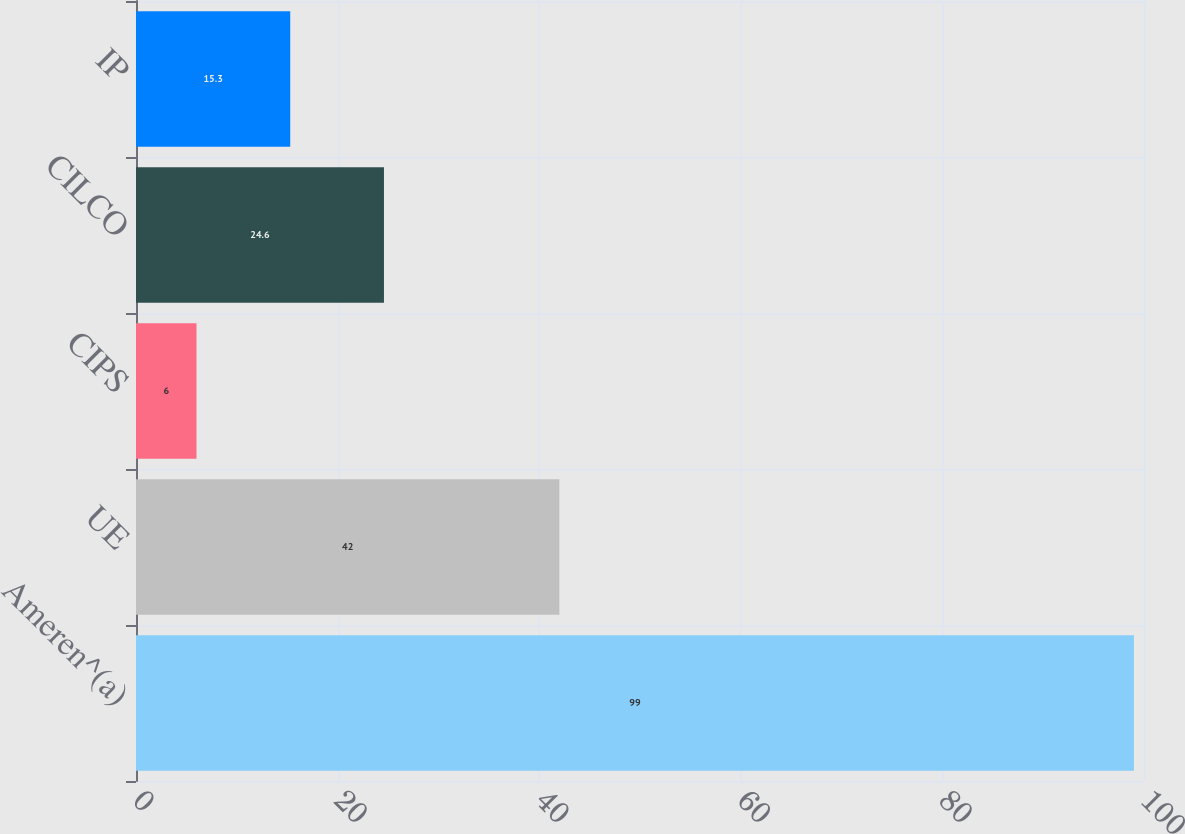<chart> <loc_0><loc_0><loc_500><loc_500><bar_chart><fcel>Ameren^(a)<fcel>UE<fcel>CIPS<fcel>CILCO<fcel>IP<nl><fcel>99<fcel>42<fcel>6<fcel>24.6<fcel>15.3<nl></chart> 